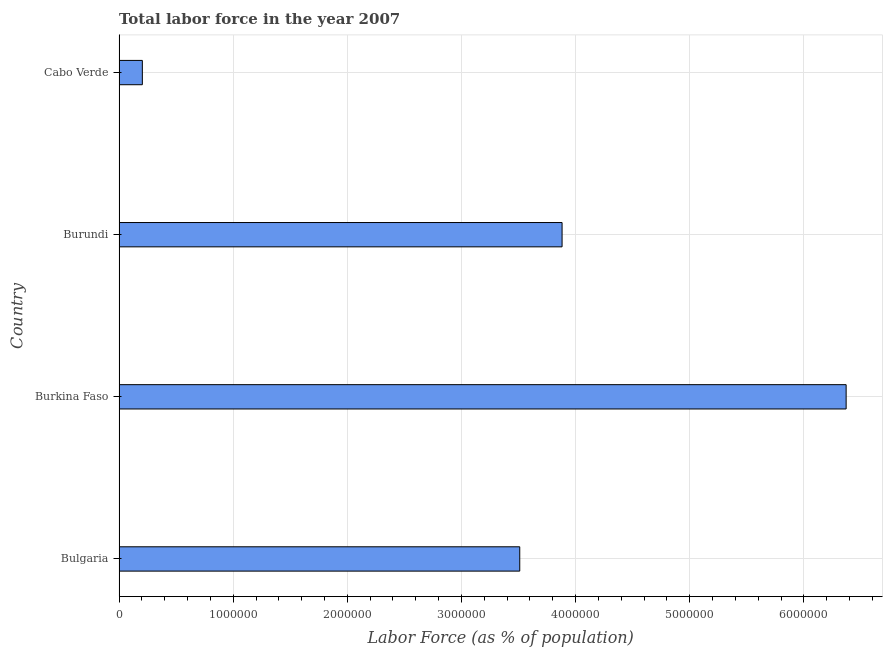Does the graph contain any zero values?
Make the answer very short. No. What is the title of the graph?
Offer a very short reply. Total labor force in the year 2007. What is the label or title of the X-axis?
Your answer should be very brief. Labor Force (as % of population). What is the total labor force in Burundi?
Provide a short and direct response. 3.88e+06. Across all countries, what is the maximum total labor force?
Provide a succinct answer. 6.37e+06. Across all countries, what is the minimum total labor force?
Provide a succinct answer. 2.04e+05. In which country was the total labor force maximum?
Provide a succinct answer. Burkina Faso. In which country was the total labor force minimum?
Make the answer very short. Cabo Verde. What is the sum of the total labor force?
Give a very brief answer. 1.40e+07. What is the difference between the total labor force in Bulgaria and Burundi?
Your response must be concise. -3.71e+05. What is the average total labor force per country?
Make the answer very short. 3.49e+06. What is the median total labor force?
Keep it short and to the point. 3.70e+06. What is the ratio of the total labor force in Burkina Faso to that in Cabo Verde?
Offer a terse response. 31.22. Is the total labor force in Burkina Faso less than that in Burundi?
Offer a terse response. No. Is the difference between the total labor force in Burkina Faso and Cabo Verde greater than the difference between any two countries?
Provide a succinct answer. Yes. What is the difference between the highest and the second highest total labor force?
Make the answer very short. 2.49e+06. What is the difference between the highest and the lowest total labor force?
Give a very brief answer. 6.17e+06. In how many countries, is the total labor force greater than the average total labor force taken over all countries?
Your answer should be very brief. 3. How many bars are there?
Make the answer very short. 4. What is the difference between two consecutive major ticks on the X-axis?
Give a very brief answer. 1.00e+06. Are the values on the major ticks of X-axis written in scientific E-notation?
Your answer should be very brief. No. What is the Labor Force (as % of population) in Bulgaria?
Provide a short and direct response. 3.51e+06. What is the Labor Force (as % of population) of Burkina Faso?
Your response must be concise. 6.37e+06. What is the Labor Force (as % of population) of Burundi?
Your answer should be compact. 3.88e+06. What is the Labor Force (as % of population) in Cabo Verde?
Give a very brief answer. 2.04e+05. What is the difference between the Labor Force (as % of population) in Bulgaria and Burkina Faso?
Give a very brief answer. -2.86e+06. What is the difference between the Labor Force (as % of population) in Bulgaria and Burundi?
Give a very brief answer. -3.71e+05. What is the difference between the Labor Force (as % of population) in Bulgaria and Cabo Verde?
Keep it short and to the point. 3.31e+06. What is the difference between the Labor Force (as % of population) in Burkina Faso and Burundi?
Your response must be concise. 2.49e+06. What is the difference between the Labor Force (as % of population) in Burkina Faso and Cabo Verde?
Keep it short and to the point. 6.17e+06. What is the difference between the Labor Force (as % of population) in Burundi and Cabo Verde?
Your response must be concise. 3.68e+06. What is the ratio of the Labor Force (as % of population) in Bulgaria to that in Burkina Faso?
Your answer should be very brief. 0.55. What is the ratio of the Labor Force (as % of population) in Bulgaria to that in Burundi?
Your answer should be very brief. 0.9. What is the ratio of the Labor Force (as % of population) in Bulgaria to that in Cabo Verde?
Provide a succinct answer. 17.2. What is the ratio of the Labor Force (as % of population) in Burkina Faso to that in Burundi?
Your response must be concise. 1.64. What is the ratio of the Labor Force (as % of population) in Burkina Faso to that in Cabo Verde?
Your response must be concise. 31.22. What is the ratio of the Labor Force (as % of population) in Burundi to that in Cabo Verde?
Provide a short and direct response. 19.02. 